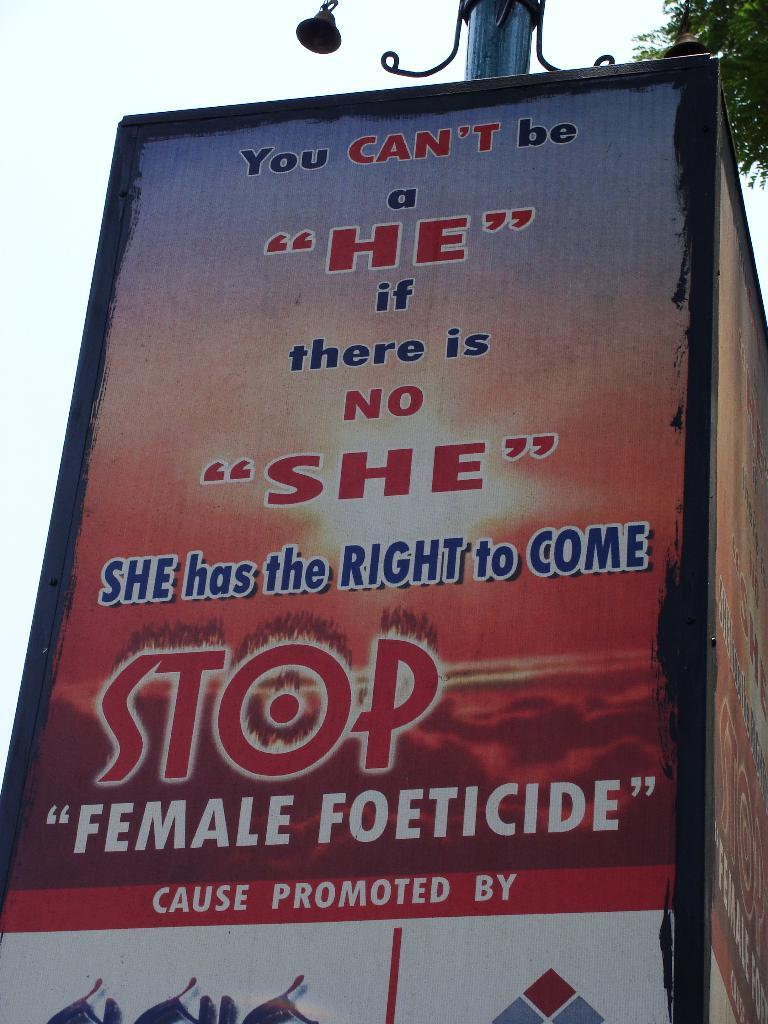Provide a one-sentence caption for the provided image. Big sign that is promoting female rights on a poster. 